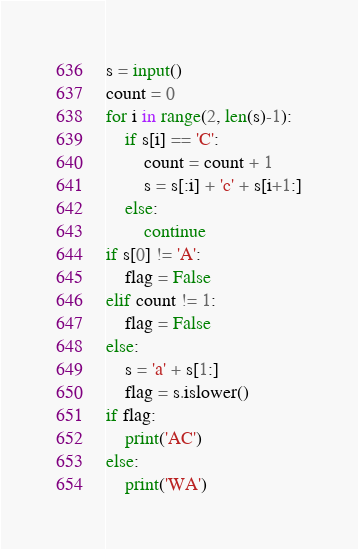<code> <loc_0><loc_0><loc_500><loc_500><_Python_>s = input()
count = 0
for i in range(2, len(s)-1):
    if s[i] == 'C':
        count = count + 1
        s = s[:i] + 'c' + s[i+1:]
    else:
        continue
if s[0] != 'A':
    flag = False
elif count != 1:
    flag = False
else:
    s = 'a' + s[1:]
    flag = s.islower()
if flag:
    print('AC')
else:
    print('WA')</code> 